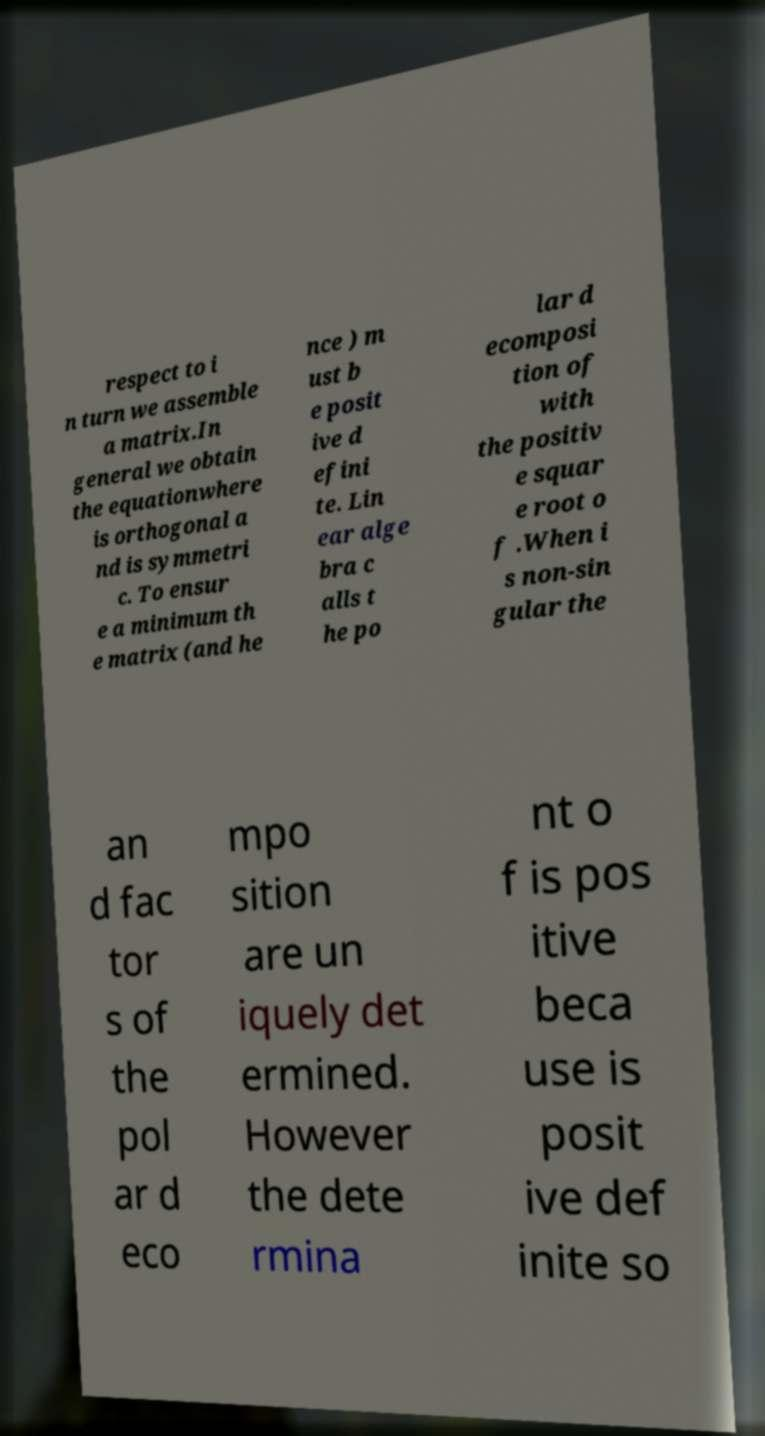What messages or text are displayed in this image? I need them in a readable, typed format. respect to i n turn we assemble a matrix.In general we obtain the equationwhere is orthogonal a nd is symmetri c. To ensur e a minimum th e matrix (and he nce ) m ust b e posit ive d efini te. Lin ear alge bra c alls t he po lar d ecomposi tion of with the positiv e squar e root o f .When i s non-sin gular the an d fac tor s of the pol ar d eco mpo sition are un iquely det ermined. However the dete rmina nt o f is pos itive beca use is posit ive def inite so 